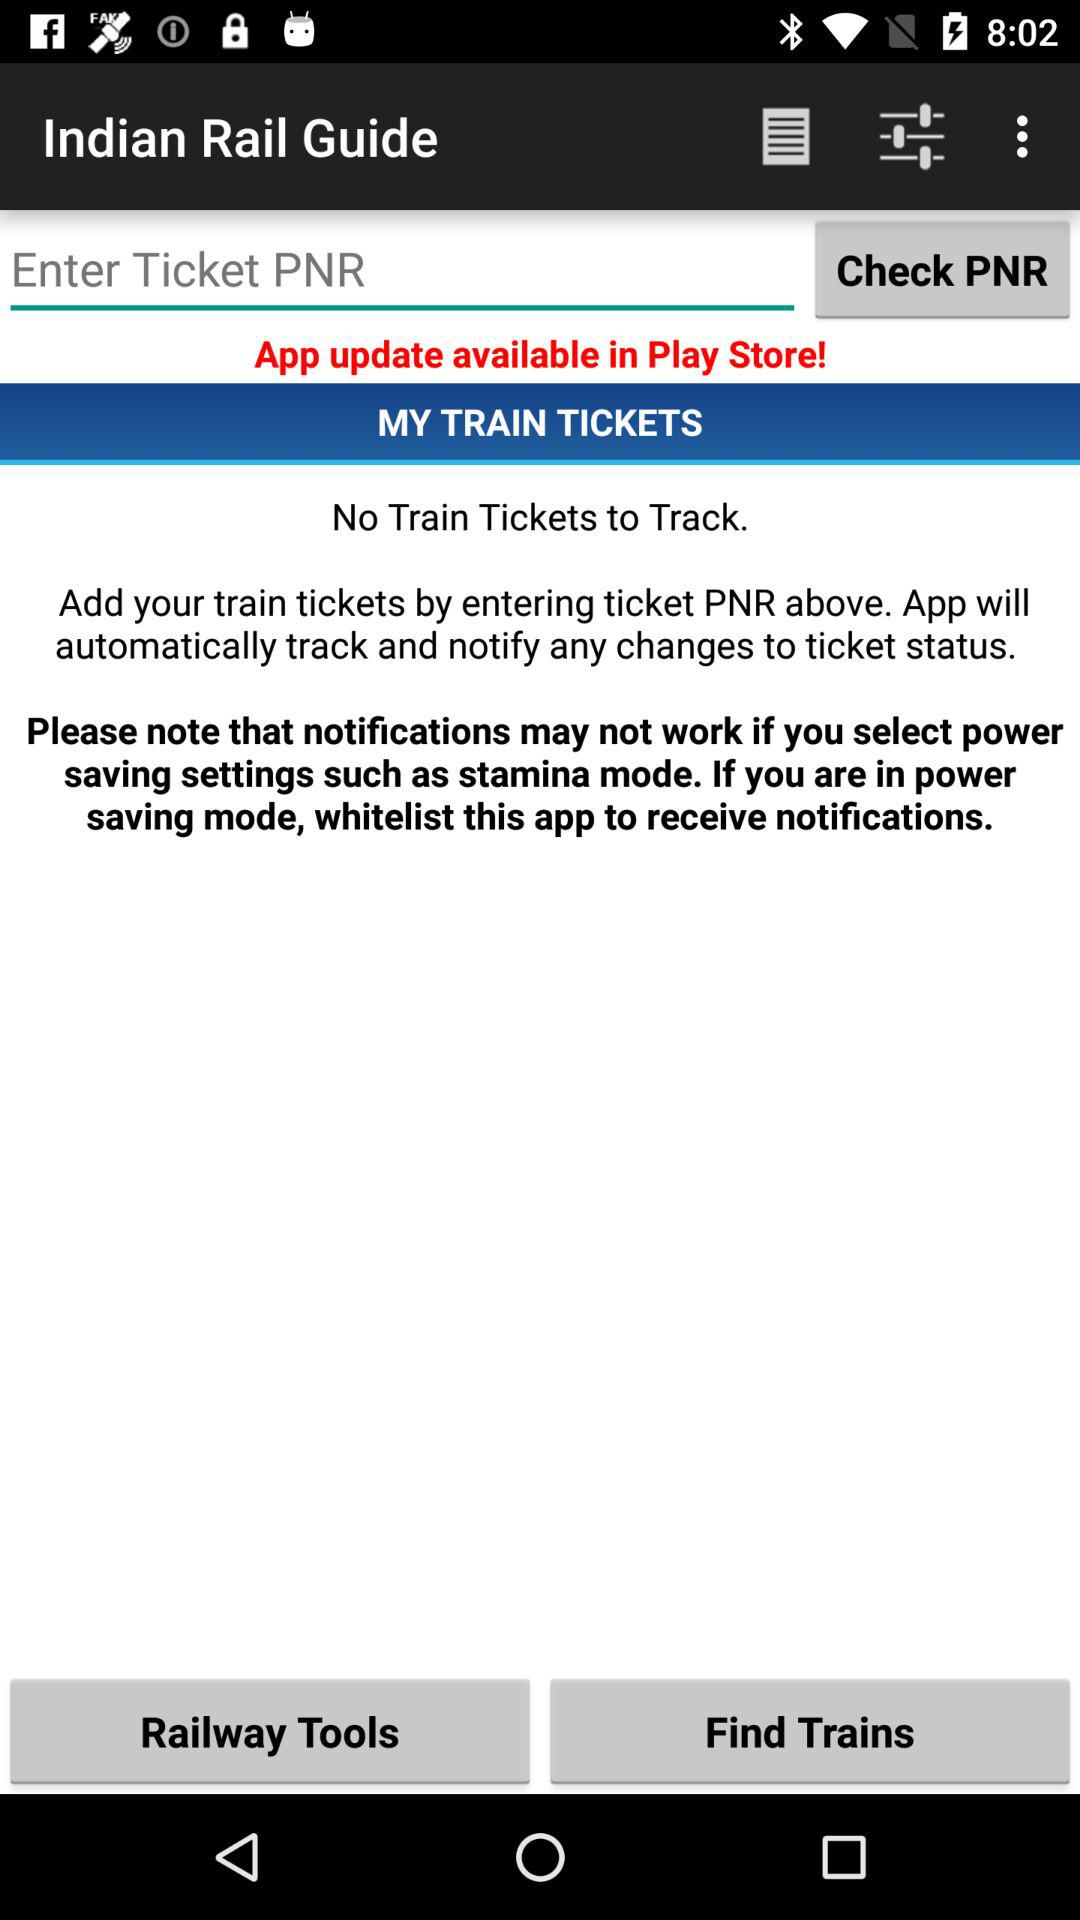From where can we update the app? You can update the app from "Play Store". 